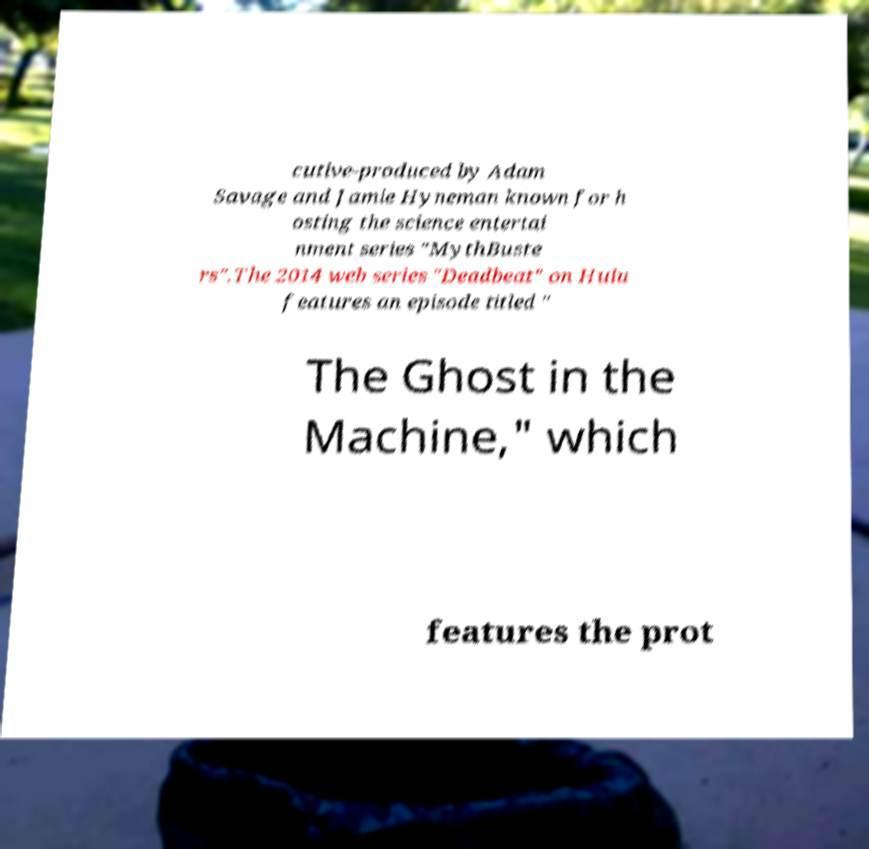Could you extract and type out the text from this image? cutive-produced by Adam Savage and Jamie Hyneman known for h osting the science entertai nment series "MythBuste rs".The 2014 web series "Deadbeat" on Hulu features an episode titled " The Ghost in the Machine," which features the prot 